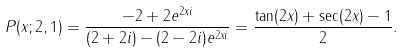Convert formula to latex. <formula><loc_0><loc_0><loc_500><loc_500>P ( x ; 2 , 1 ) & = \frac { - 2 + 2 e ^ { 2 x i } } { ( 2 + 2 i ) - ( 2 - 2 i ) e ^ { 2 x i } } = \frac { \tan ( 2 x ) + \sec ( 2 x ) - 1 } { 2 } .</formula> 